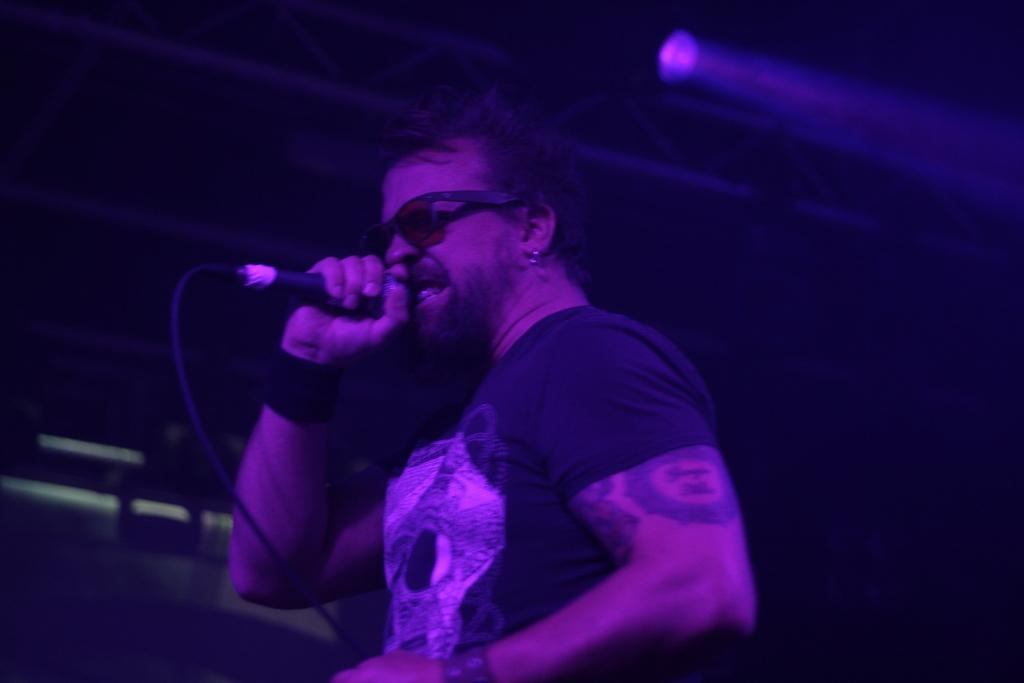What is the man in the image doing? The man is standing in the image and holding a mic in his hand. What accessory is the man wearing in the image? The man is wearing sunglasses. What can be seen in the background of the image? There are lightings visible in the image. What type of road can be seen in the image? There is no road visible in the image. 